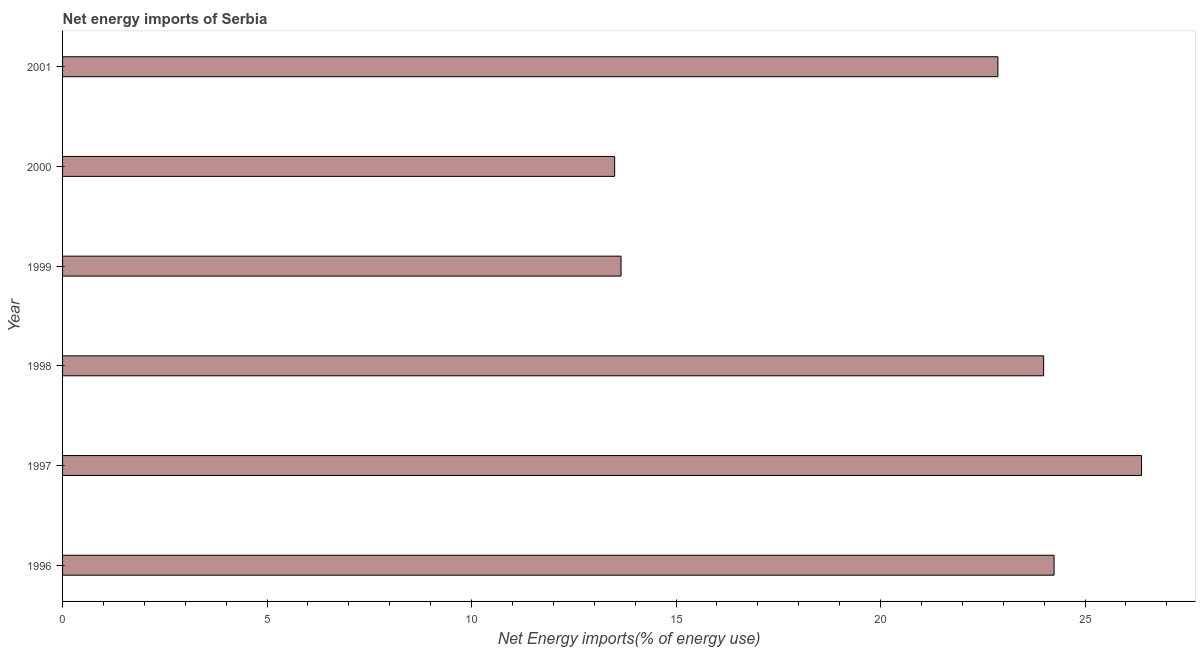Does the graph contain any zero values?
Your answer should be compact. No. Does the graph contain grids?
Provide a succinct answer. No. What is the title of the graph?
Ensure brevity in your answer.  Net energy imports of Serbia. What is the label or title of the X-axis?
Provide a succinct answer. Net Energy imports(% of energy use). What is the energy imports in 1997?
Provide a short and direct response. 26.38. Across all years, what is the maximum energy imports?
Your response must be concise. 26.38. Across all years, what is the minimum energy imports?
Ensure brevity in your answer.  13.5. What is the sum of the energy imports?
Keep it short and to the point. 124.64. What is the difference between the energy imports in 1997 and 2000?
Offer a terse response. 12.88. What is the average energy imports per year?
Keep it short and to the point. 20.77. What is the median energy imports?
Ensure brevity in your answer.  23.43. In how many years, is the energy imports greater than 21 %?
Provide a succinct answer. 4. What is the ratio of the energy imports in 1998 to that in 2000?
Your response must be concise. 1.78. Is the difference between the energy imports in 1997 and 2001 greater than the difference between any two years?
Your answer should be very brief. No. What is the difference between the highest and the second highest energy imports?
Your answer should be compact. 2.14. What is the difference between the highest and the lowest energy imports?
Provide a succinct answer. 12.88. In how many years, is the energy imports greater than the average energy imports taken over all years?
Make the answer very short. 4. How many bars are there?
Your answer should be compact. 6. How many years are there in the graph?
Your response must be concise. 6. What is the difference between two consecutive major ticks on the X-axis?
Offer a very short reply. 5. What is the Net Energy imports(% of energy use) in 1996?
Your answer should be compact. 24.24. What is the Net Energy imports(% of energy use) of 1997?
Offer a very short reply. 26.38. What is the Net Energy imports(% of energy use) of 1998?
Your answer should be compact. 23.99. What is the Net Energy imports(% of energy use) of 1999?
Offer a very short reply. 13.66. What is the Net Energy imports(% of energy use) of 2000?
Provide a succinct answer. 13.5. What is the Net Energy imports(% of energy use) in 2001?
Ensure brevity in your answer.  22.87. What is the difference between the Net Energy imports(% of energy use) in 1996 and 1997?
Your answer should be compact. -2.14. What is the difference between the Net Energy imports(% of energy use) in 1996 and 1998?
Provide a succinct answer. 0.26. What is the difference between the Net Energy imports(% of energy use) in 1996 and 1999?
Your answer should be very brief. 10.59. What is the difference between the Net Energy imports(% of energy use) in 1996 and 2000?
Your response must be concise. 10.74. What is the difference between the Net Energy imports(% of energy use) in 1996 and 2001?
Ensure brevity in your answer.  1.37. What is the difference between the Net Energy imports(% of energy use) in 1997 and 1998?
Your answer should be compact. 2.39. What is the difference between the Net Energy imports(% of energy use) in 1997 and 1999?
Make the answer very short. 12.73. What is the difference between the Net Energy imports(% of energy use) in 1997 and 2000?
Make the answer very short. 12.88. What is the difference between the Net Energy imports(% of energy use) in 1997 and 2001?
Offer a very short reply. 3.51. What is the difference between the Net Energy imports(% of energy use) in 1998 and 1999?
Your answer should be very brief. 10.33. What is the difference between the Net Energy imports(% of energy use) in 1998 and 2000?
Your response must be concise. 10.49. What is the difference between the Net Energy imports(% of energy use) in 1998 and 2001?
Your response must be concise. 1.12. What is the difference between the Net Energy imports(% of energy use) in 1999 and 2000?
Keep it short and to the point. 0.16. What is the difference between the Net Energy imports(% of energy use) in 1999 and 2001?
Your answer should be very brief. -9.21. What is the difference between the Net Energy imports(% of energy use) in 2000 and 2001?
Offer a very short reply. -9.37. What is the ratio of the Net Energy imports(% of energy use) in 1996 to that in 1997?
Your answer should be compact. 0.92. What is the ratio of the Net Energy imports(% of energy use) in 1996 to that in 1999?
Your answer should be very brief. 1.77. What is the ratio of the Net Energy imports(% of energy use) in 1996 to that in 2000?
Keep it short and to the point. 1.8. What is the ratio of the Net Energy imports(% of energy use) in 1996 to that in 2001?
Your answer should be very brief. 1.06. What is the ratio of the Net Energy imports(% of energy use) in 1997 to that in 1999?
Your response must be concise. 1.93. What is the ratio of the Net Energy imports(% of energy use) in 1997 to that in 2000?
Offer a terse response. 1.95. What is the ratio of the Net Energy imports(% of energy use) in 1997 to that in 2001?
Give a very brief answer. 1.15. What is the ratio of the Net Energy imports(% of energy use) in 1998 to that in 1999?
Your answer should be very brief. 1.76. What is the ratio of the Net Energy imports(% of energy use) in 1998 to that in 2000?
Offer a terse response. 1.78. What is the ratio of the Net Energy imports(% of energy use) in 1998 to that in 2001?
Give a very brief answer. 1.05. What is the ratio of the Net Energy imports(% of energy use) in 1999 to that in 2001?
Give a very brief answer. 0.6. What is the ratio of the Net Energy imports(% of energy use) in 2000 to that in 2001?
Make the answer very short. 0.59. 